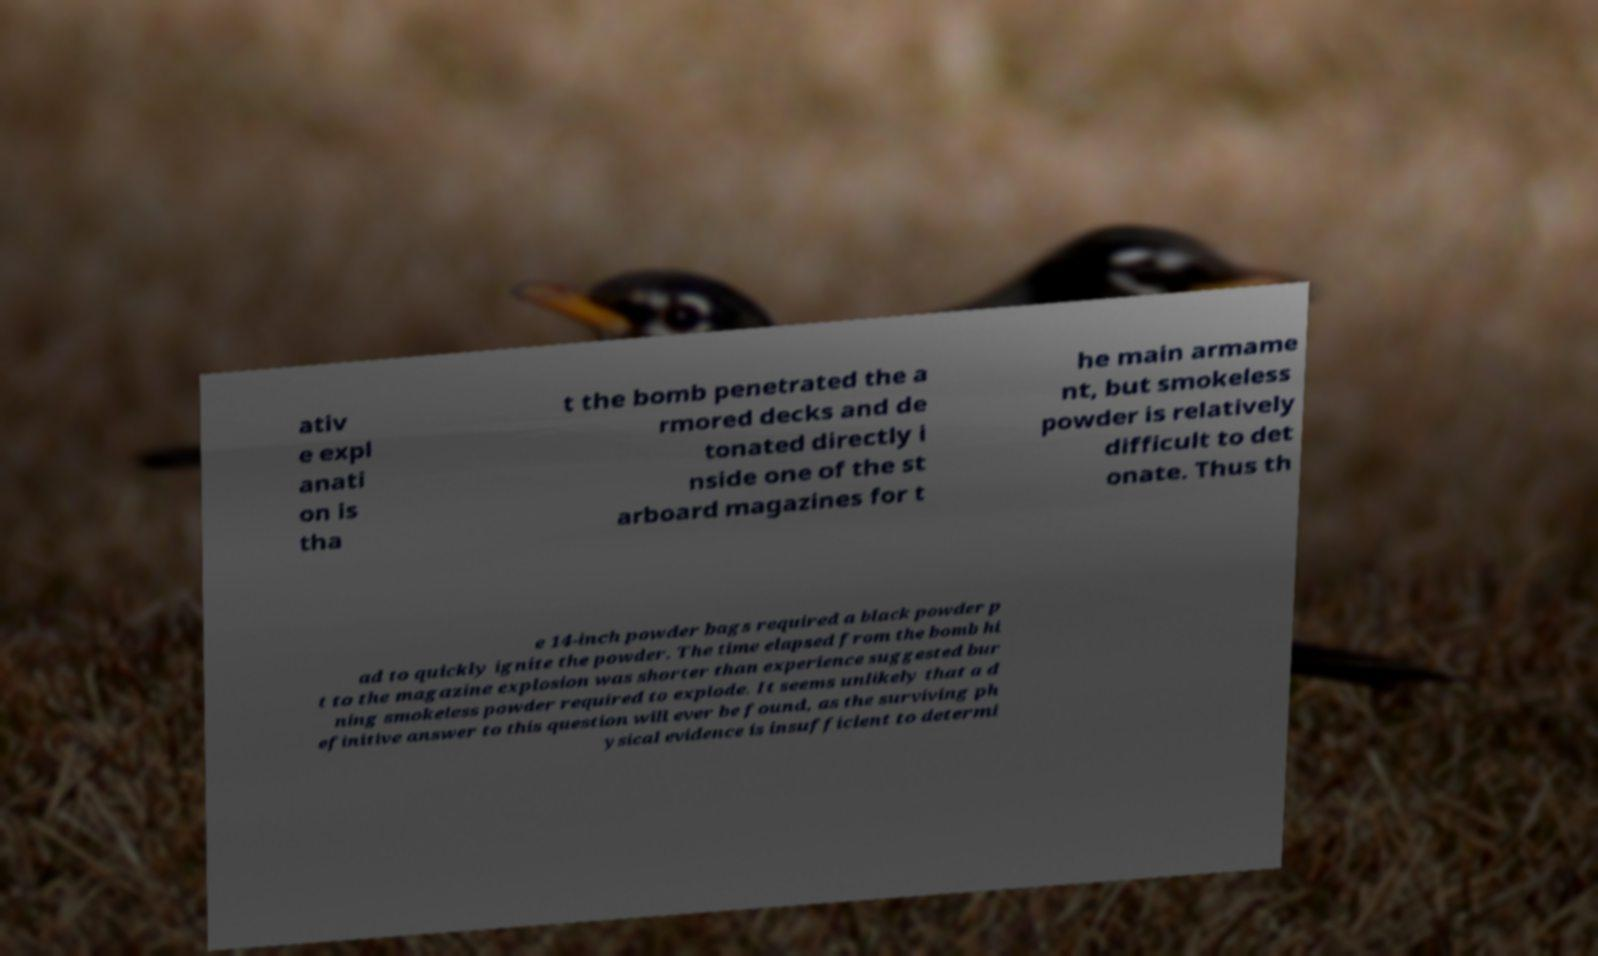I need the written content from this picture converted into text. Can you do that? ativ e expl anati on is tha t the bomb penetrated the a rmored decks and de tonated directly i nside one of the st arboard magazines for t he main armame nt, but smokeless powder is relatively difficult to det onate. Thus th e 14-inch powder bags required a black powder p ad to quickly ignite the powder. The time elapsed from the bomb hi t to the magazine explosion was shorter than experience suggested bur ning smokeless powder required to explode. It seems unlikely that a d efinitive answer to this question will ever be found, as the surviving ph ysical evidence is insufficient to determi 